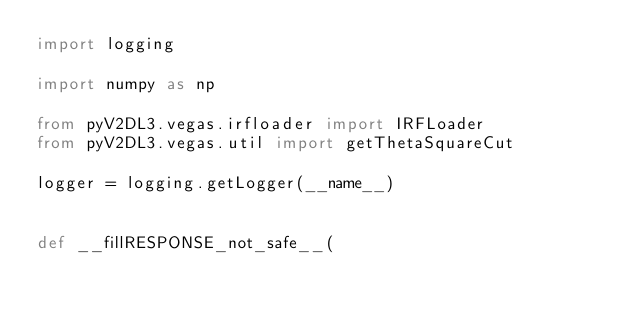Convert code to text. <code><loc_0><loc_0><loc_500><loc_500><_Python_>import logging

import numpy as np

from pyV2DL3.vegas.irfloader import IRFLoader
from pyV2DL3.vegas.util import getThetaSquareCut

logger = logging.getLogger(__name__)


def __fillRESPONSE_not_safe__(</code> 